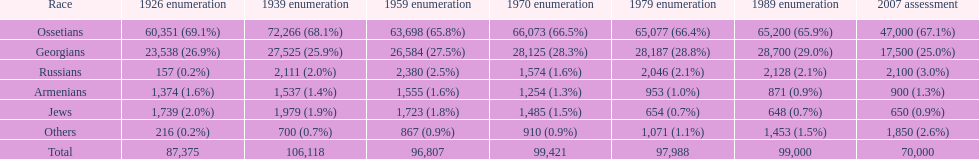How many russians lived in south ossetia in 1970? 1,574. 